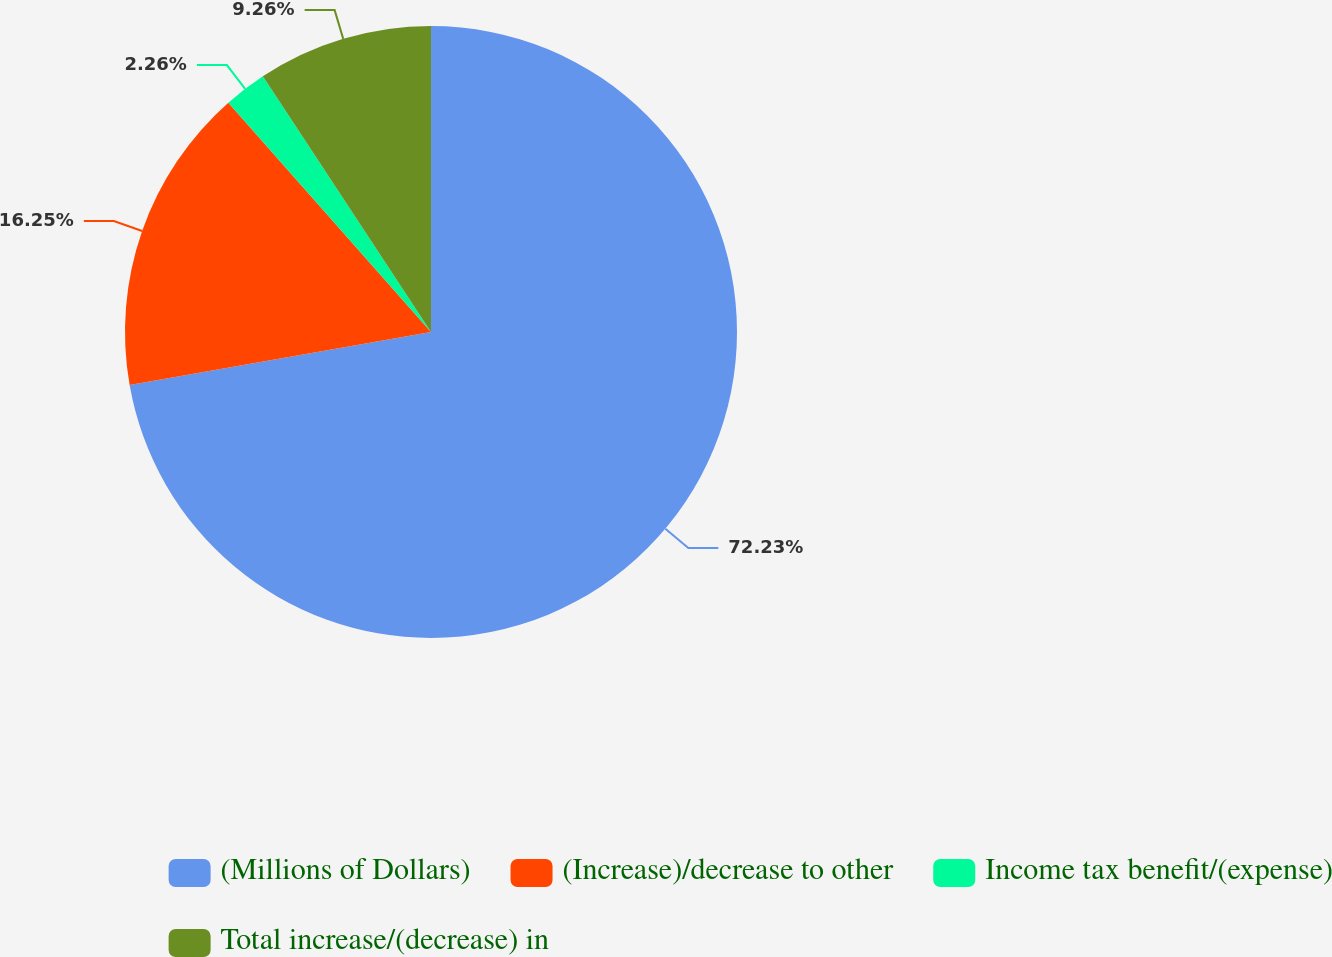<chart> <loc_0><loc_0><loc_500><loc_500><pie_chart><fcel>(Millions of Dollars)<fcel>(Increase)/decrease to other<fcel>Income tax benefit/(expense)<fcel>Total increase/(decrease) in<nl><fcel>72.23%<fcel>16.25%<fcel>2.26%<fcel>9.26%<nl></chart> 